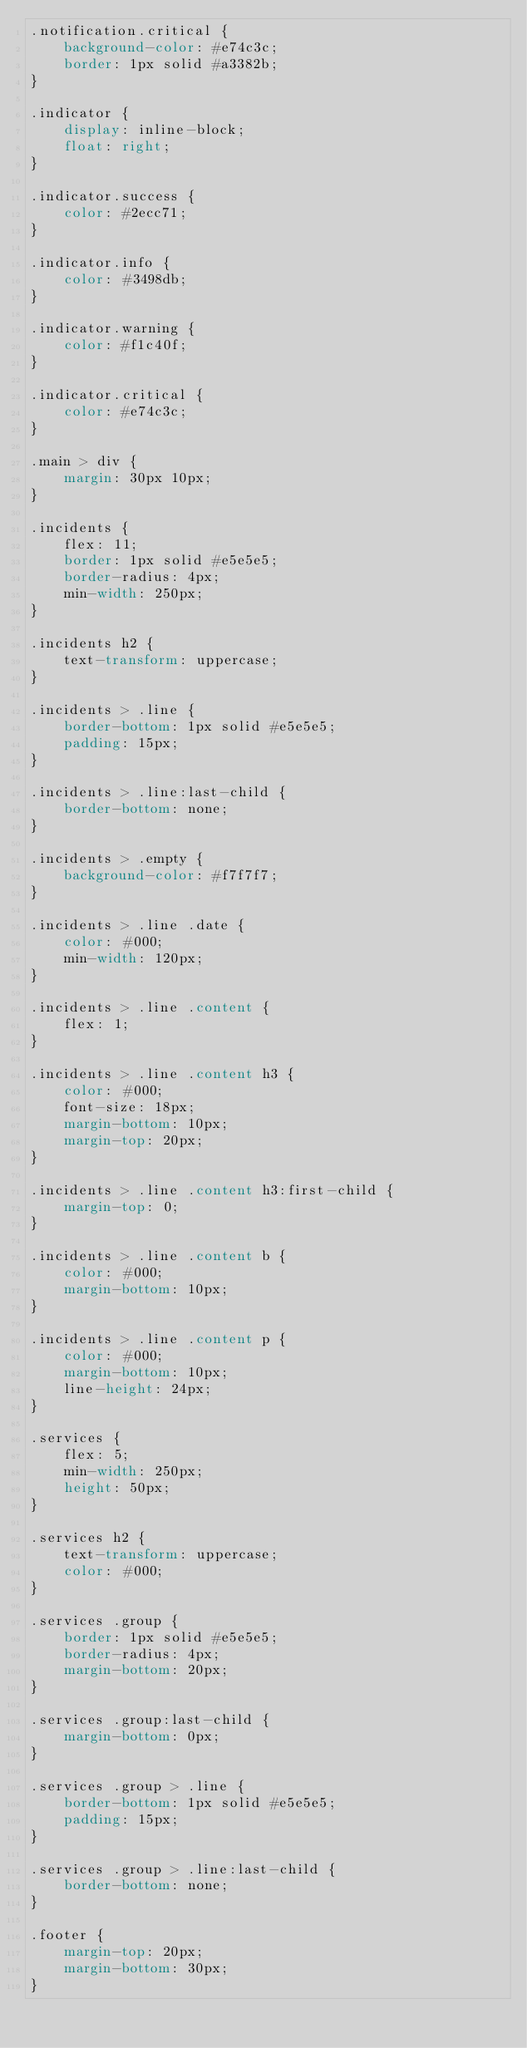<code> <loc_0><loc_0><loc_500><loc_500><_CSS_>.notification.critical {
    background-color: #e74c3c;
    border: 1px solid #a3382b;
}

.indicator {
    display: inline-block;
    float: right;
}

.indicator.success {
    color: #2ecc71;
}

.indicator.info {
    color: #3498db;
}

.indicator.warning {
    color: #f1c40f;
}

.indicator.critical {
    color: #e74c3c;
}

.main > div {
    margin: 30px 10px;
}

.incidents {
    flex: 11;
    border: 1px solid #e5e5e5;
    border-radius: 4px;
    min-width: 250px;
}

.incidents h2 {
    text-transform: uppercase;
}

.incidents > .line {
    border-bottom: 1px solid #e5e5e5;
    padding: 15px;
}

.incidents > .line:last-child {
    border-bottom: none;
}

.incidents > .empty {
    background-color: #f7f7f7;
}

.incidents > .line .date {
    color: #000;
    min-width: 120px;
}

.incidents > .line .content {
    flex: 1;
}

.incidents > .line .content h3 {
    color: #000;
    font-size: 18px;
    margin-bottom: 10px;
    margin-top: 20px;
}

.incidents > .line .content h3:first-child {
    margin-top: 0;
}

.incidents > .line .content b {
    color: #000;
    margin-bottom: 10px;
}

.incidents > .line .content p {
    color: #000;
    margin-bottom: 10px;
    line-height: 24px;
}

.services {
    flex: 5;
    min-width: 250px;
    height: 50px;
}

.services h2 {
    text-transform: uppercase;
    color: #000;
}

.services .group {
    border: 1px solid #e5e5e5;
    border-radius: 4px;
    margin-bottom: 20px;
}

.services .group:last-child {
    margin-bottom: 0px;
}

.services .group > .line {
    border-bottom: 1px solid #e5e5e5;
    padding: 15px;
}

.services .group > .line:last-child {
    border-bottom: none;
}

.footer {
    margin-top: 20px;
    margin-bottom: 30px;
}
</code> 